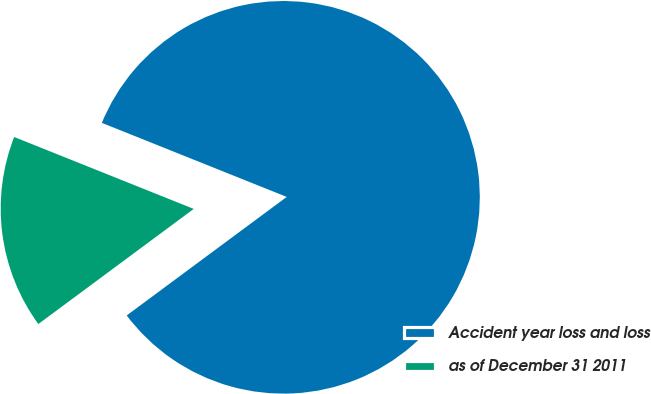Convert chart. <chart><loc_0><loc_0><loc_500><loc_500><pie_chart><fcel>Accident year loss and loss<fcel>as of December 31 2011<nl><fcel>83.79%<fcel>16.21%<nl></chart> 